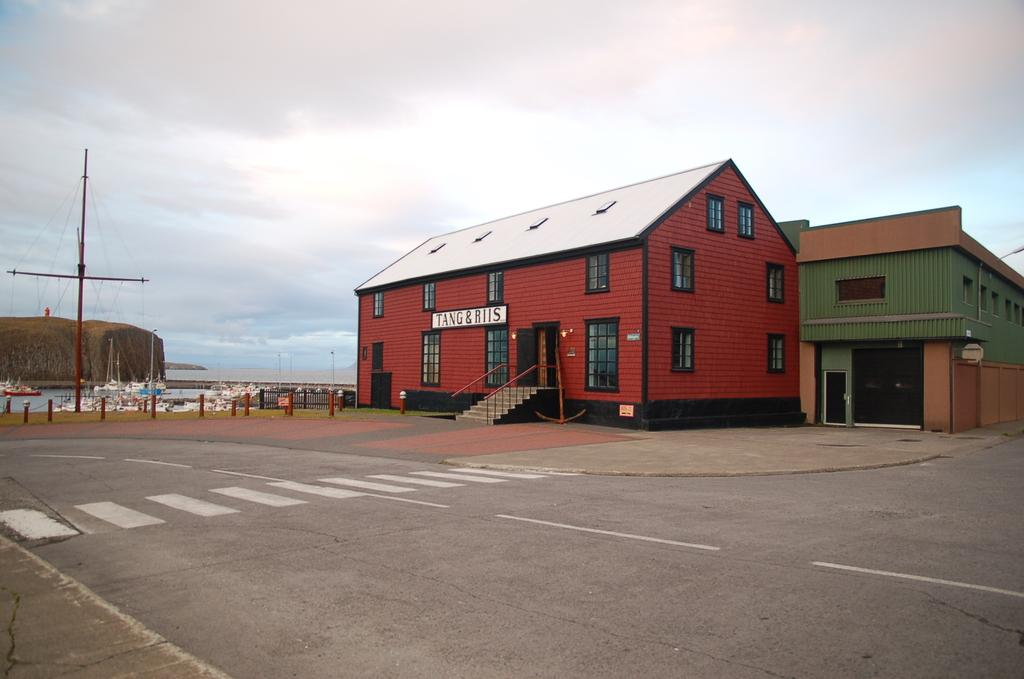What type of surface can be seen in the image? There is a road in the image. What structure is present in the image? There is a building in the image. What sign is visible in the image? There is a name board in the image. What architectural feature can be seen in the image? There are windows and steps in the image. What are the poles used for in the image? The poles are likely used for supporting wires or cables in the image. What natural element is present in the image? There are rocks in the image. What mode of transportation can be seen in the image? There are boats on water in the image. What objects are present in the image? There are objects in the image, but their specific nature is not mentioned. What is visible in the background of the image? The sky is visible in the background of the image, with clouds present. How many fingers can be seen on the person in the image? There is no person present in the image, so it is not possible to determine the number of fingers. What type of education is being taught in the image? There is no indication of any educational activity in the image. 